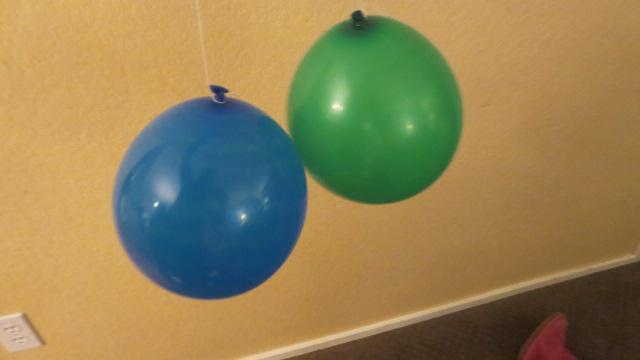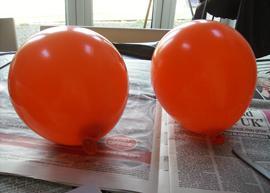The first image is the image on the left, the second image is the image on the right. Evaluate the accuracy of this statement regarding the images: "A total of three balloons are shown, and one image contains only a pink-colored balloon.". Is it true? Answer yes or no. No. The first image is the image on the left, the second image is the image on the right. For the images displayed, is the sentence "There are more balloons in the image on the right." factually correct? Answer yes or no. No. 